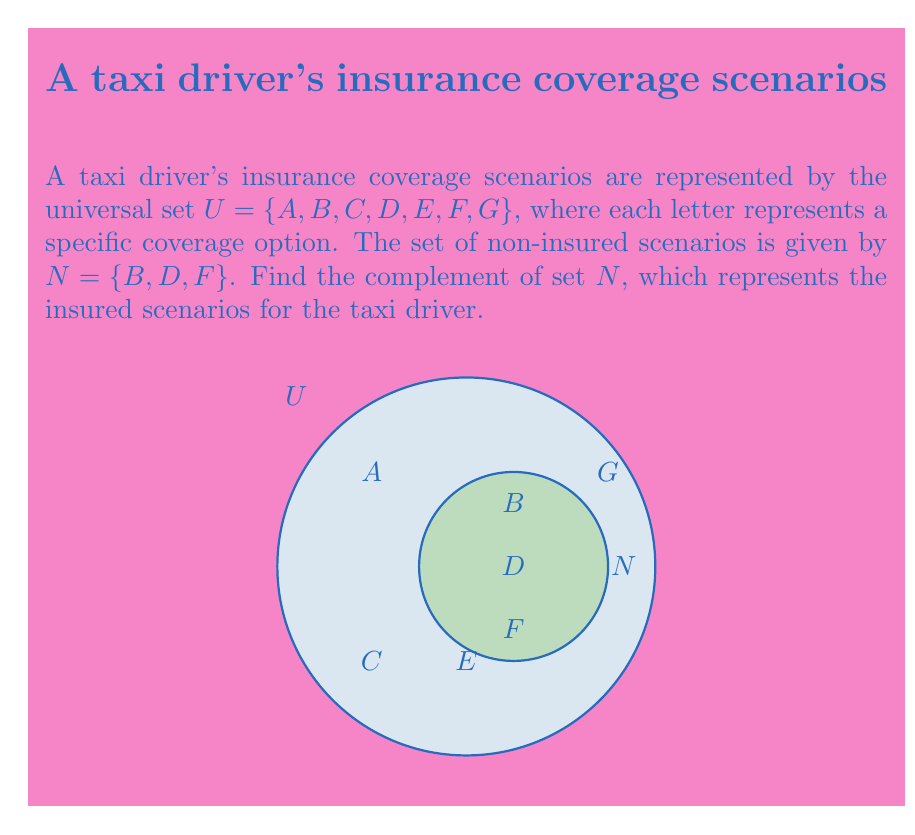Give your solution to this math problem. To find the complement of set $N$, we need to identify all elements in the universal set $U$ that are not in set $N$. Let's approach this step-by-step:

1) The universal set $U = \{A, B, C, D, E, F, G\}$
2) The set of non-insured scenarios $N = \{B, D, F\}$
3) The complement of $N$, denoted as $N^c$, will contain all elements in $U$ that are not in $N$

4) Let's go through each element in $U$:
   - $A$ is not in $N$, so it's in $N^c$
   - $B$ is in $N$, so it's not in $N^c$
   - $C$ is not in $N$, so it's in $N^c$
   - $D$ is in $N$, so it's not in $N^c$
   - $E$ is not in $N$, so it's in $N^c$
   - $F$ is in $N$, so it's not in $N^c$
   - $G$ is not in $N$, so it's in $N^c$

5) Therefore, the complement of $N$ is $N^c = \{A, C, E, G\}$

This set $N^c$ represents all the insured scenarios for the taxi driver.
Answer: $N^c = \{A, C, E, G\}$ 